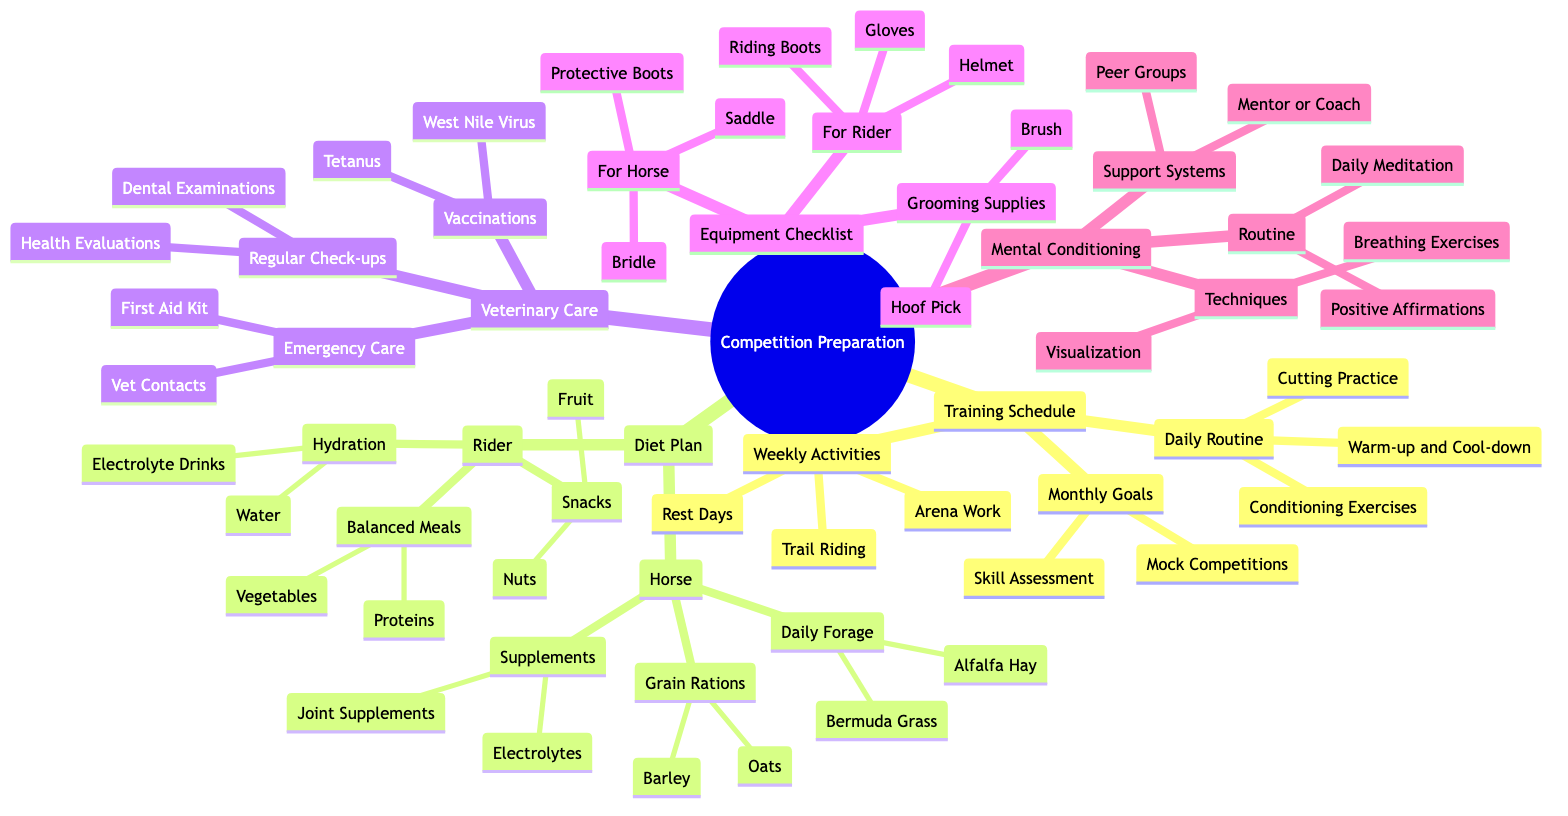What are the monthly goals in the Training Schedule? The diagram lists two monthly goals under the Training Schedule section: 'Skill Assessment with Trainer' and 'Mock Competitions'. These are found in the 'Monthly Goals' node.
Answer: Skill Assessment with Trainer, Mock Competitions How many daily routines are outlined in the Training Schedule? In the Training Schedule section, the 'Daily Routine' node contains three items: Warm-up and Cool-down, Cutting Practice, and Conditioning and Stamina Exercises. Therefore, the total number is three.
Answer: 3 What are the two types of supplements for the horse? When looking at the horse's diet plan, there are two specific supplements listed under the 'Supplements' node: 'Electrolytes' and 'Joint Supplements'. This is a direct relation to a specific child node in the Diet Plan.
Answer: Electrolytes, Joint Supplements What techniques are included in Mental Conditioning? The diagram shows two techniques listed under the 'Techniques' node of the Mental Conditioning section: 'Visualization' and 'Breathing Exercises'. They can be found under the 'Mental Conditioning' umbrella node.
Answer: Visualization, Breathing Exercises How many items are on the Equipment Checklist for the rider? The 'Equipment Checklist' section shows three items listed under 'For Rider': 'Helmet', 'Riding Boots', and 'Gloves'. Therefore, the total number of items is three.
Answer: 3 Which services are included under Regular Check-ups in Veterinary Care? Under 'Regular Check-ups', the diagram details two services: 'Dental Examinations' and 'General Health Evaluations'. These services can be identified from the veterinary care node.
Answer: Dental Examinations, General Health Evaluations What is the purpose of Trail Riding in the Weekly Activities? Trail Riding is listed as one of the 'Weekly Activities' aimed at providing a 'Mental Break', as indicated in the node for weekly activities in the Training Schedule. This shows it serves a dual role in the training routine.
Answer: Mental Break Who can be part of the Support Systems in Mental Conditioning? The 'Support Systems' in the Mental Conditioning section lists two potential sources of support: a 'Mentor or Coach' and 'Peer Support Groups'. This implies that community and mentorship play crucial roles in mental preparedness.
Answer: Mentor or Coach, Peer Support Groups 